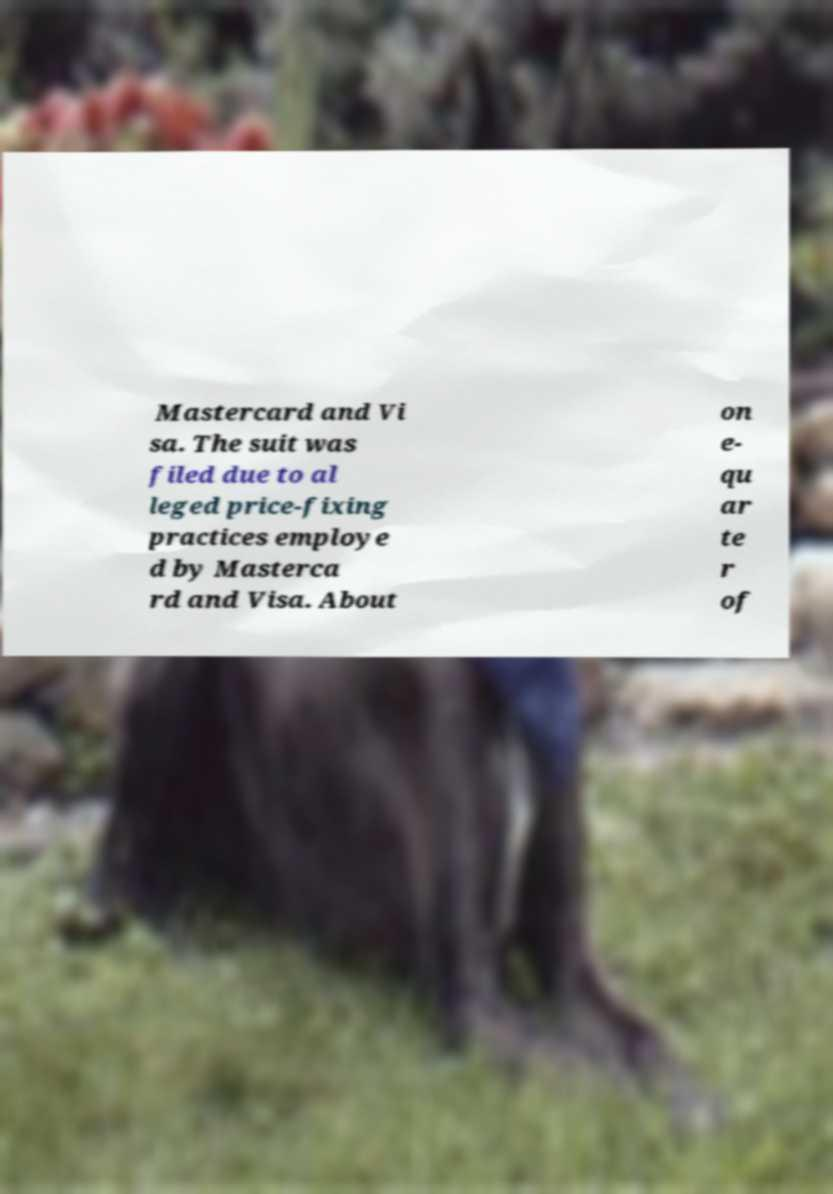Please read and relay the text visible in this image. What does it say? Mastercard and Vi sa. The suit was filed due to al leged price-fixing practices employe d by Masterca rd and Visa. About on e- qu ar te r of 